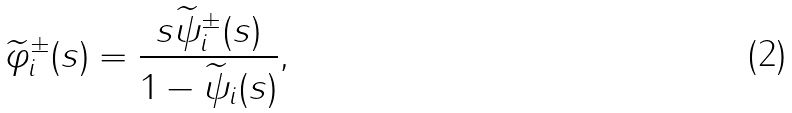<formula> <loc_0><loc_0><loc_500><loc_500>\widetilde { \varphi } _ { i } ^ { \pm } ( s ) = \frac { s \widetilde { \psi } _ { i } ^ { \pm } ( s ) } { 1 - \widetilde { \psi } _ { i } ( s ) } ,</formula> 